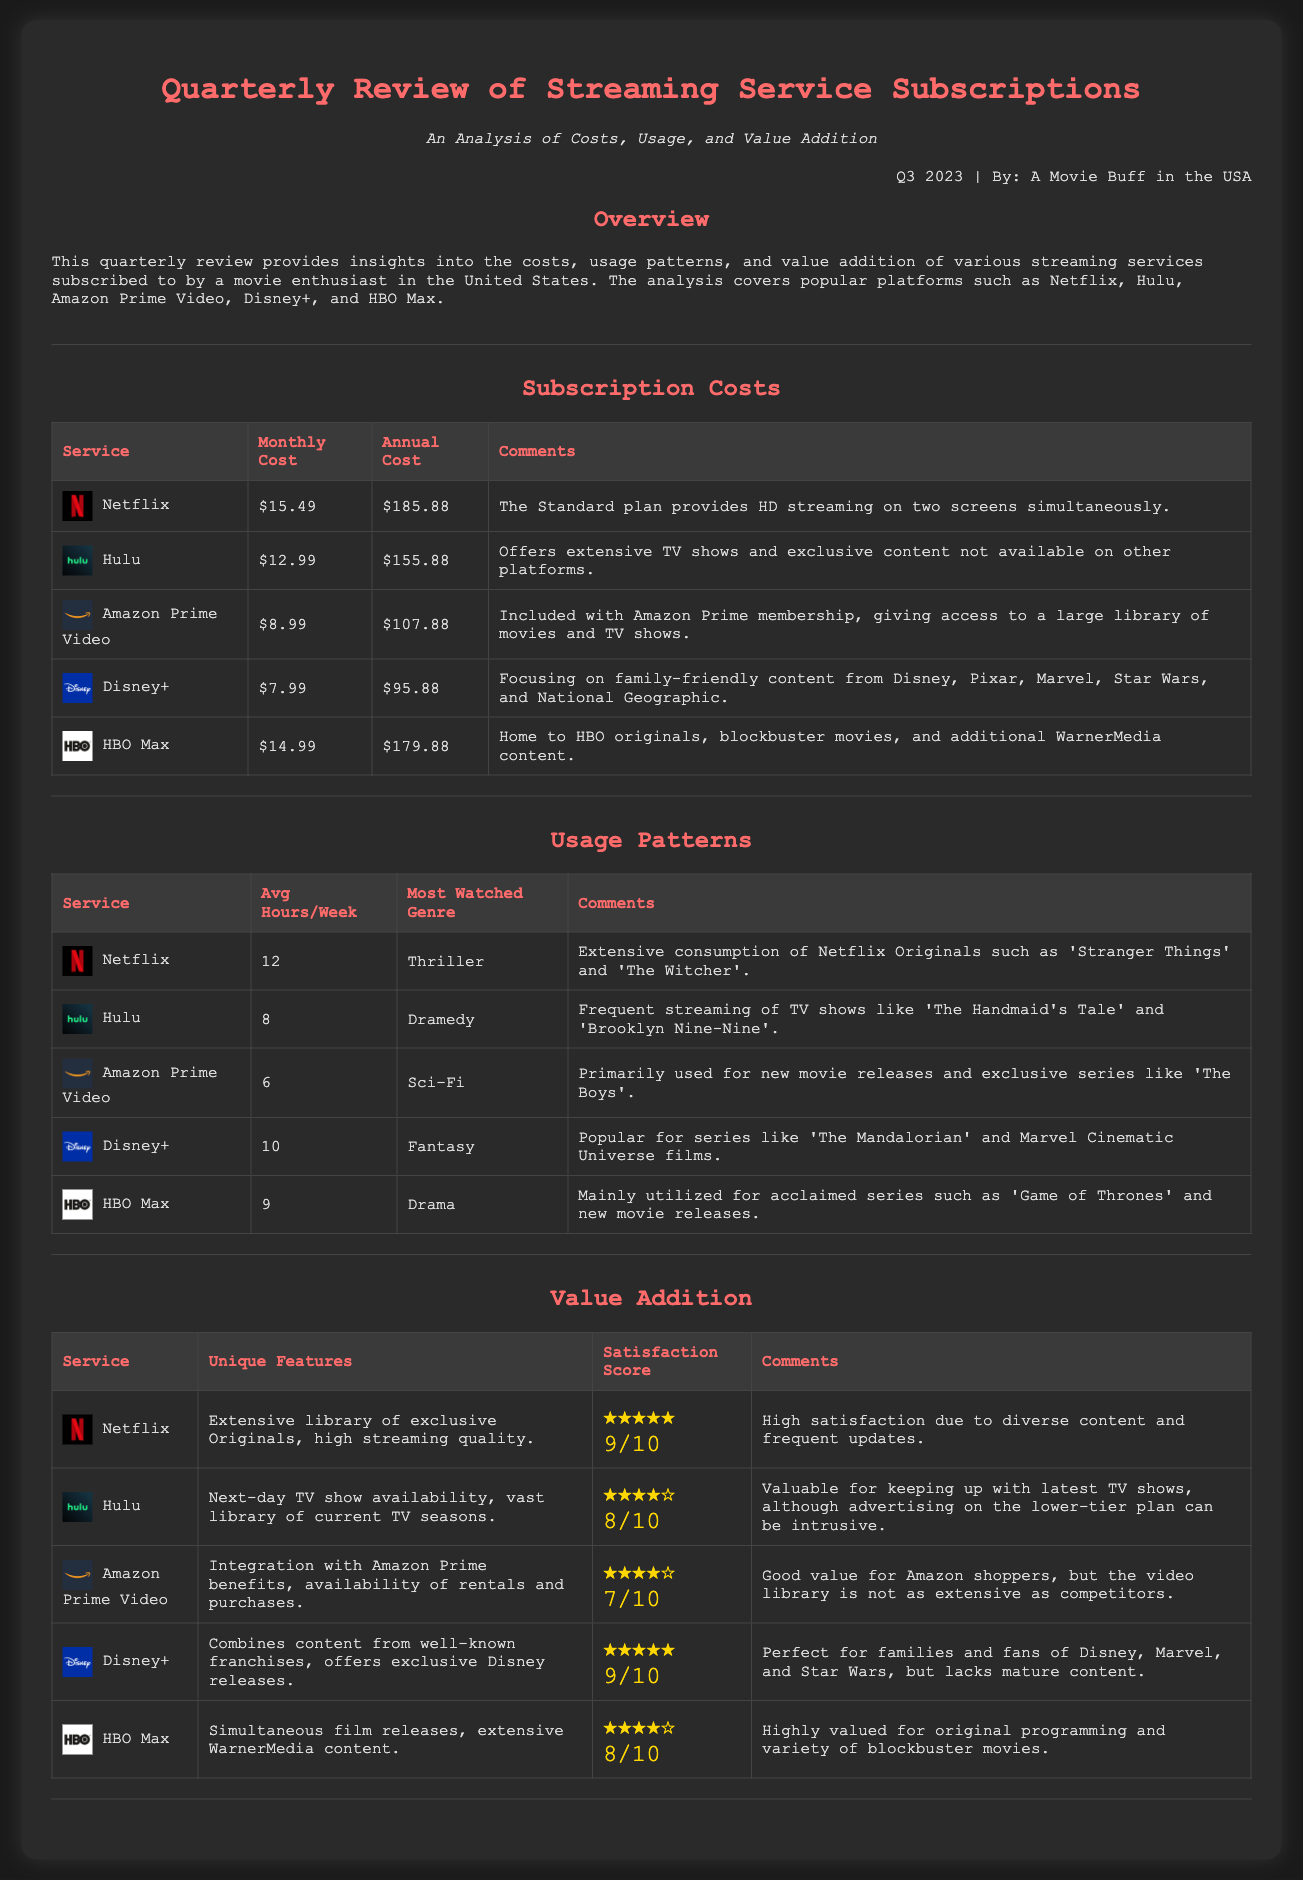What is the monthly cost of Hulu? The monthly cost of Hulu is highlighted in the subscription costs section of the document.
Answer: $12.99 How many average hours per week is Netflix used? The average hours per week for Netflix usage is provided in the usage patterns section of the document.
Answer: 12 What unique feature does Disney+ offer? The unique features of Disney+ are listed in the value addition section of the document.
Answer: Combines content from well-known franchises What is the annual cost of Amazon Prime Video? The annual cost of Amazon Prime Video can be found in the subscription costs table.
Answer: $107.88 Which streaming service has the highest satisfaction score? By comparing the satisfaction scores presented in the value addition section, we can identify which service is the highest rated.
Answer: Netflix What is the most watched genre on HBO Max? The most watched genre for HBO Max is included in the usage patterns table.
Answer: Drama Which platform focuses on family-friendly content? The document outlines the content focus for each platform, specifically mentioning family-friendly content for one.
Answer: Disney+ What is the average satisfaction score for Hulu? The average satisfaction score for Hulu is indicated in the value addition section.
Answer: 8/10 